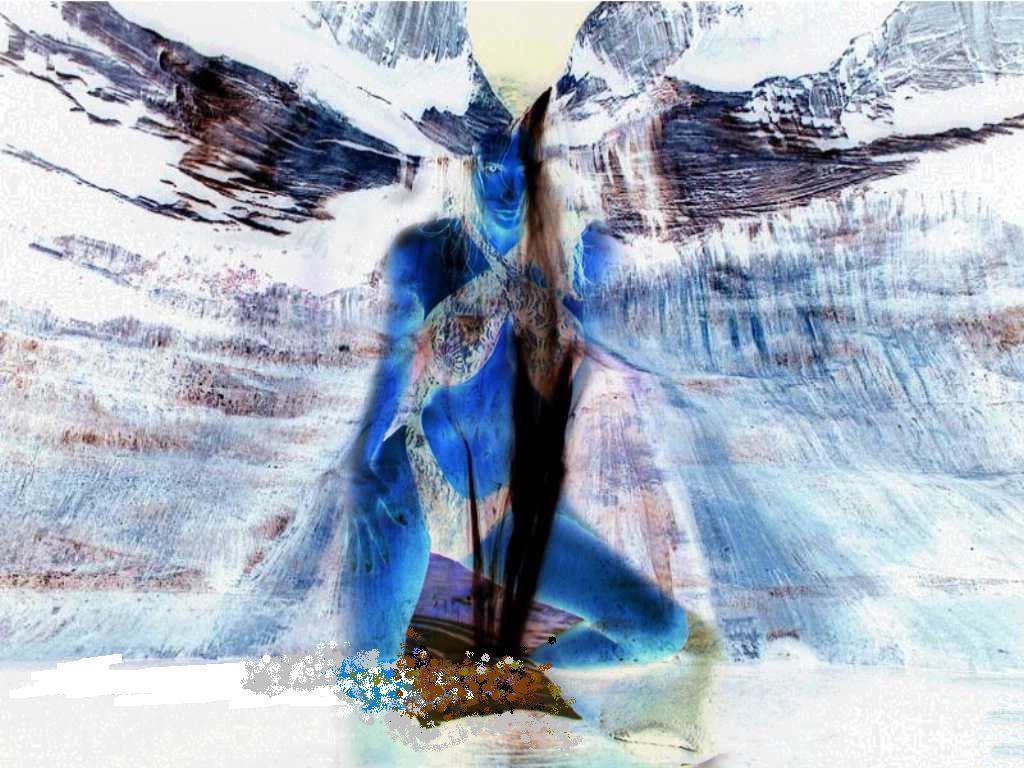In one or two sentences, can you explain what this image depicts? This picture looks like a graphical image of a woman. 